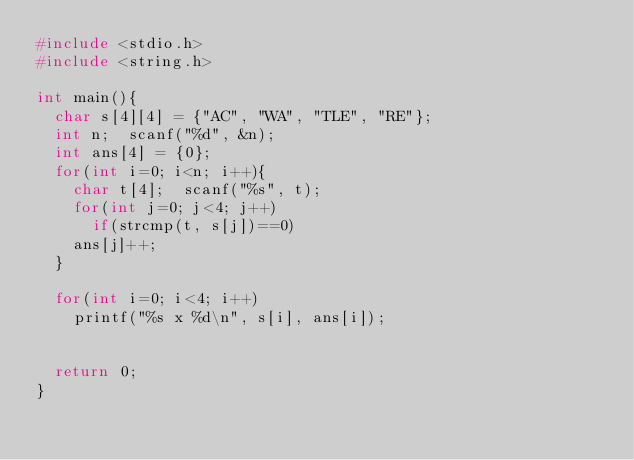<code> <loc_0><loc_0><loc_500><loc_500><_C_>#include <stdio.h>
#include <string.h>

int main(){
  char s[4][4] = {"AC", "WA", "TLE", "RE"};
  int n;  scanf("%d", &n);
  int ans[4] = {0};
  for(int i=0; i<n; i++){
    char t[4];  scanf("%s", t);
    for(int j=0; j<4; j++)
      if(strcmp(t, s[j])==0)
	ans[j]++;
  }
  
  for(int i=0; i<4; i++)
    printf("%s x %d\n", s[i], ans[i]);


  return 0;
}
  
</code> 